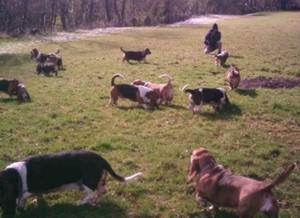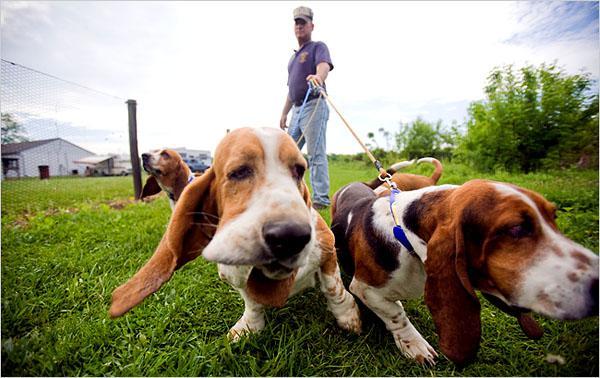The first image is the image on the left, the second image is the image on the right. For the images displayed, is the sentence "One of the images shows at least one dog on a leash." factually correct? Answer yes or no. Yes. 